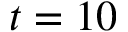Convert formula to latex. <formula><loc_0><loc_0><loc_500><loc_500>t = 1 0</formula> 